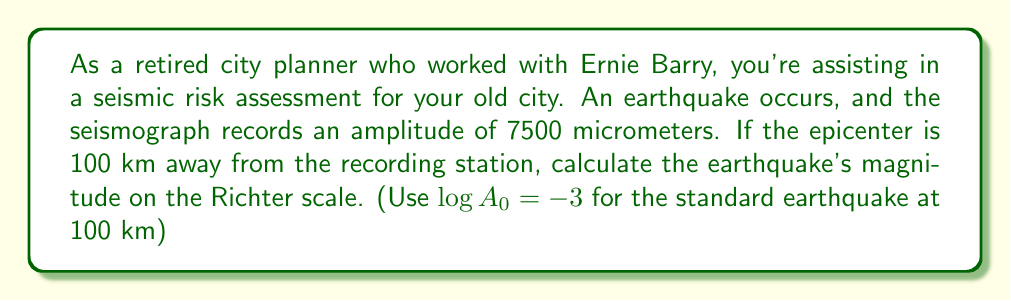Can you solve this math problem? To solve this problem, we'll use the Richter scale formula:

$$M = \log A - \log A_0$$

Where:
$M$ is the magnitude on the Richter scale
$A$ is the maximum amplitude recorded by the seismograph (in micrometers)
$A_0$ is the amplitude of a standard earthquake at the same distance

Given:
- $A = 7500$ micrometers
- Distance to epicenter = 100 km
- $\log A_0 = -3$ for a standard earthquake at 100 km

Step 1: Calculate $\log A$
$$\log A = \log 7500 = 3.875$$

Step 2: Substitute the values into the Richter scale formula
$$\begin{align}
M &= \log A - \log A_0 \\
&= 3.875 - (-3) \\
&= 3.875 + 3 \\
&= 6.875
\end{align}$$

Step 3: Round to one decimal place (as is standard for Richter scale measurements)
$$M \approx 6.9$$
Answer: 6.9 